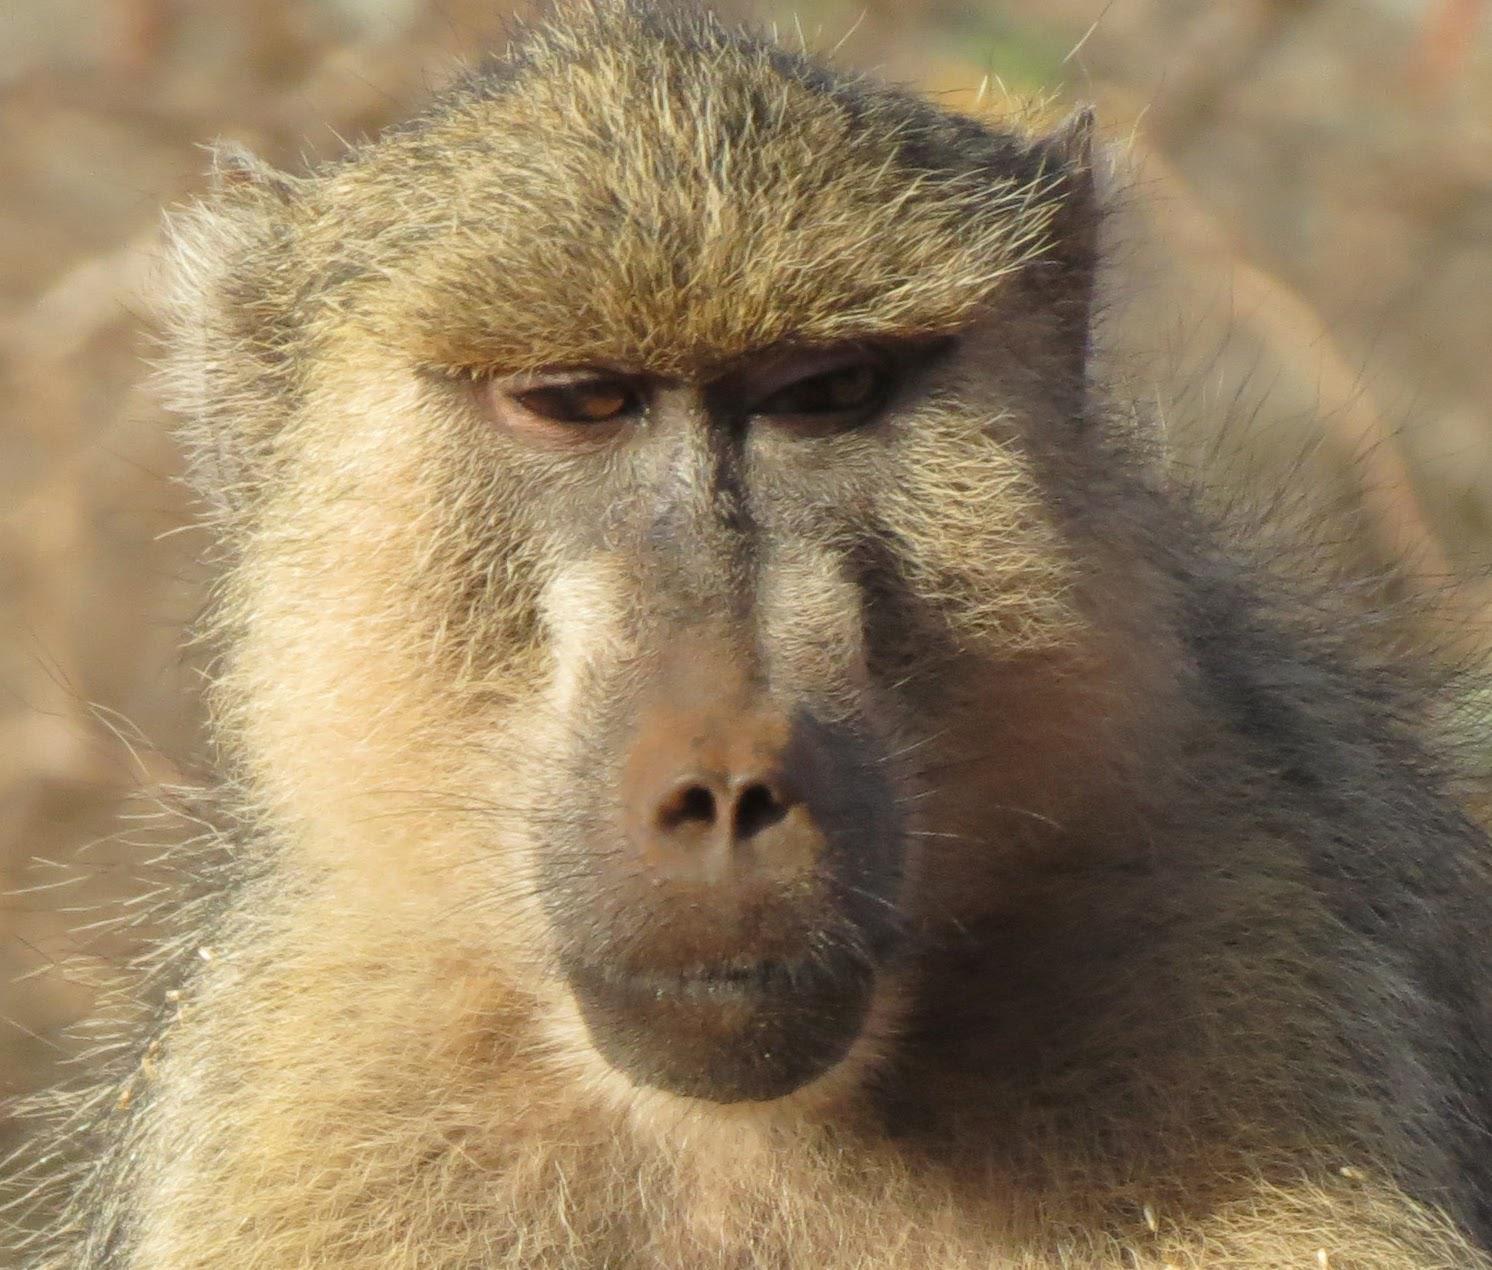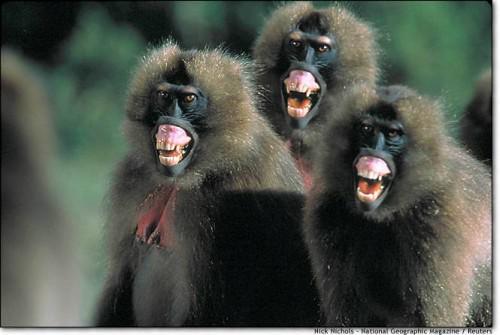The first image is the image on the left, the second image is the image on the right. For the images displayed, is the sentence "There is exactly one animal baring its teeth in the image on the right." factually correct? Answer yes or no. No. 